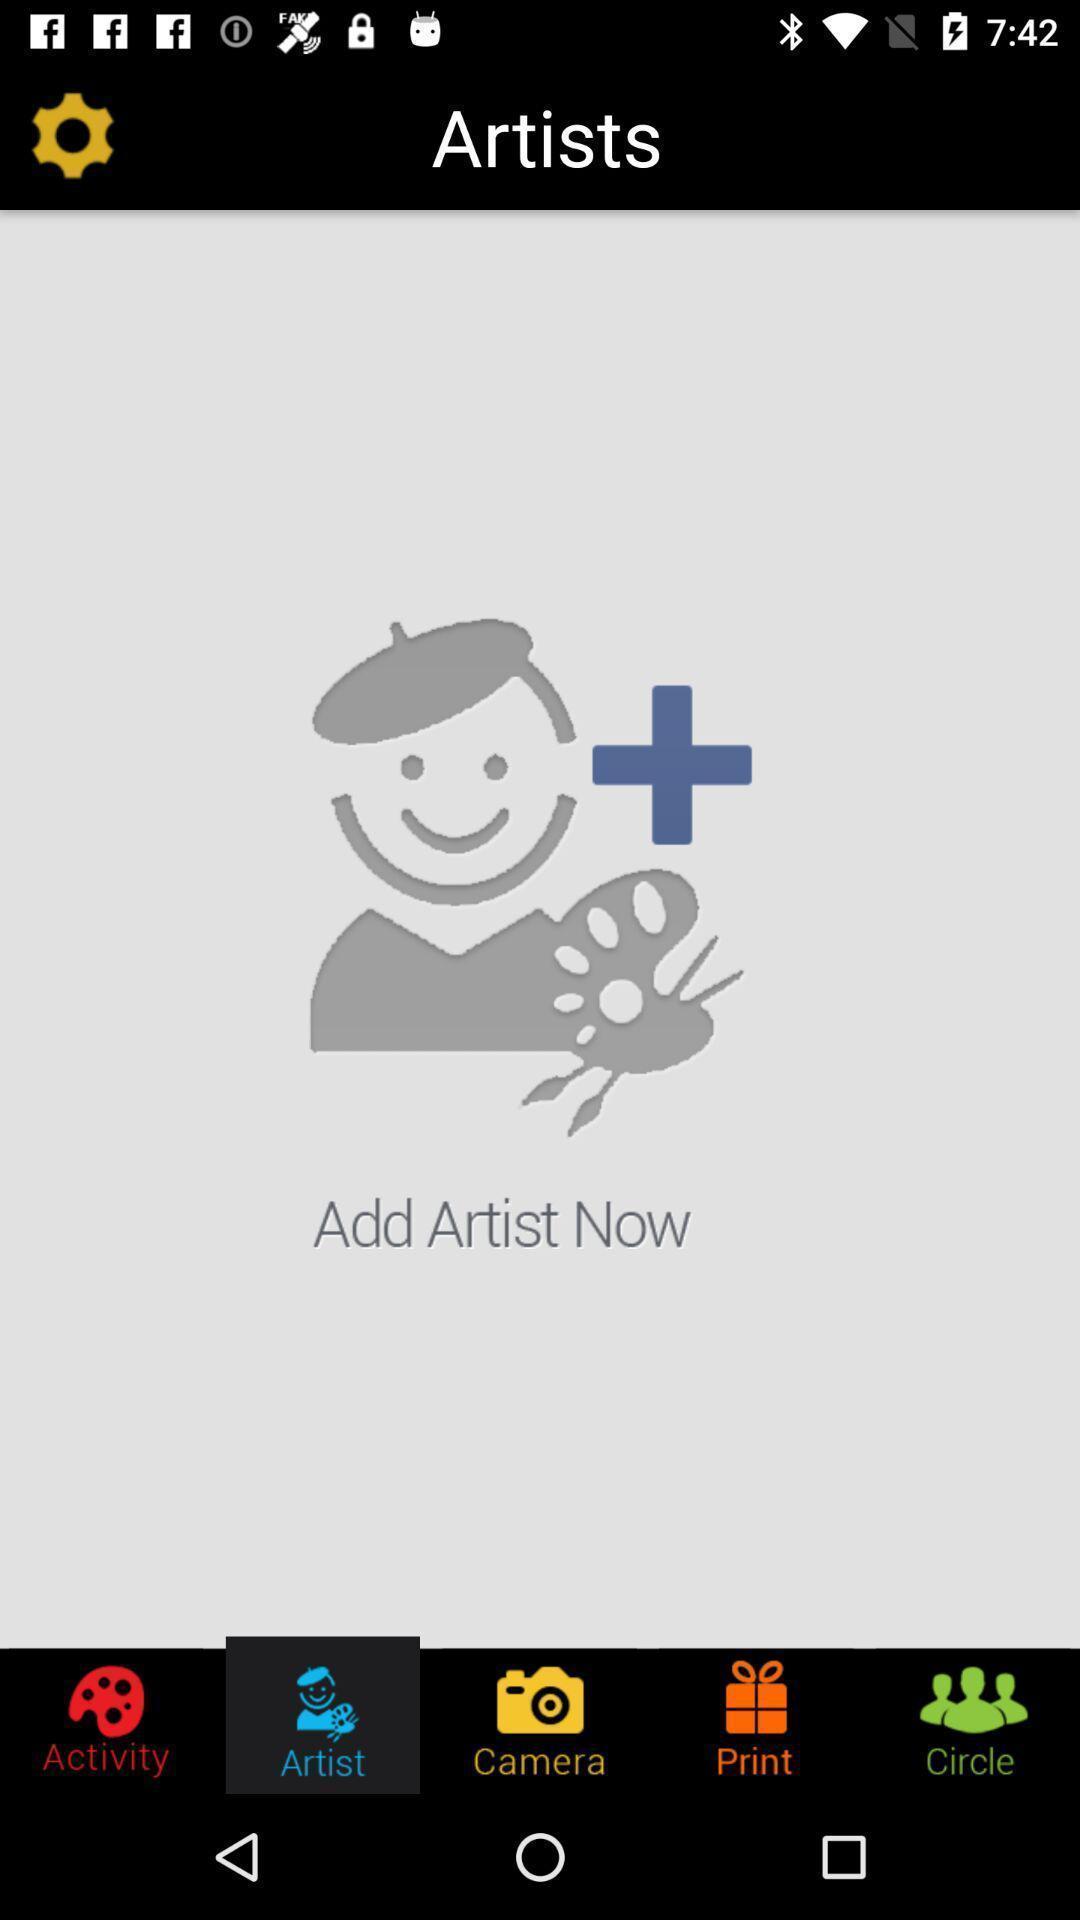Give me a narrative description of this picture. Screen displaying the artist page. 